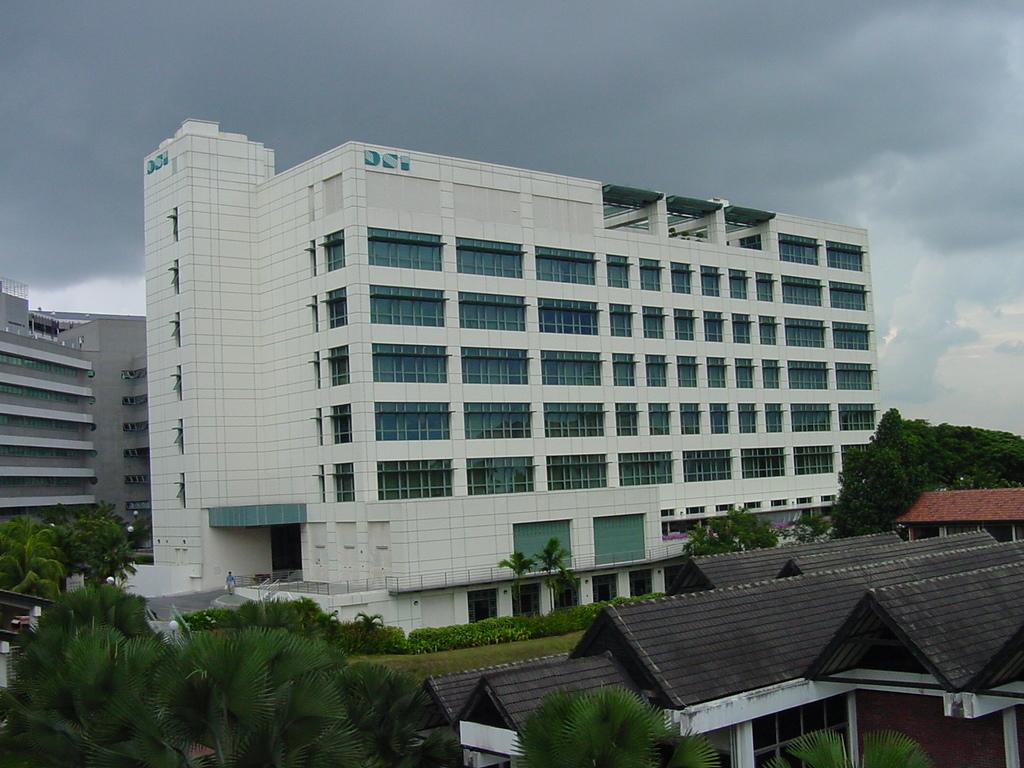What types of structures can be seen in the image? There are buildings and houses in the image. What natural elements are present in the image? There are trees and plants in the image. What objects can be seen on a surface in the image? There are glasses in the image. What architectural features are visible in the image? There are walls in the image. What can be seen in the background of the image? The sky is visible in the background of the image, and it appears to be cloudy. How many waves can be seen crashing on the shore in the image? There are no waves or shore present in the image; it features buildings, houses, trees, plants, glasses, walls, and a cloudy sky. What scientific discovery is being made in the image? There is no scientific discovery or experiment depicted in the image. 